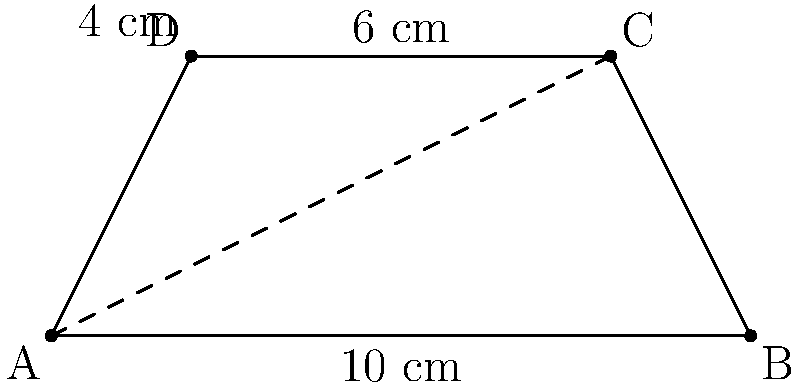Your new trapezoid-shaped mixing console has parallel sides of 10 cm and 6 cm, with a height of 4 cm. If the diagonal from the bottom left corner to the top right corner forms an angle of 30° with the bottom side, what is the area of the mixing console in square centimeters? Let's approach this step-by-step:

1) First, we need to find the length of the diagonal AC. We can use the tangent function:

   $\tan 30° = \frac{4}{\text{AC}}$

2) We know that $\tan 30° = \frac{1}{\sqrt{3}}$, so:

   $\frac{1}{\sqrt{3}} = \frac{4}{\text{AC}}$

3) Solving for AC:

   $\text{AC} = 4\sqrt{3} \approx 6.93$ cm

4) Now we can find the length of BC using the Pythagorean theorem:

   $\text{BC}^2 = \text{AC}^2 - 4^2$
   $\text{BC}^2 = (4\sqrt{3})^2 - 4^2 = 48 - 16 = 32$
   $\text{BC} = \sqrt{32} = 4\sqrt{2} \approx 5.66$ cm

5) The area of a trapezoid is given by the formula:

   $\text{Area} = \frac{a + b}{2} \cdot h$

   Where $a$ and $b$ are the parallel sides and $h$ is the height.

6) Plugging in our values:

   $\text{Area} = \frac{10 + 6}{2} \cdot 4 = 8 \cdot 4 = 32$ cm²

Therefore, the area of the mixing console is 32 square centimeters.
Answer: 32 cm² 